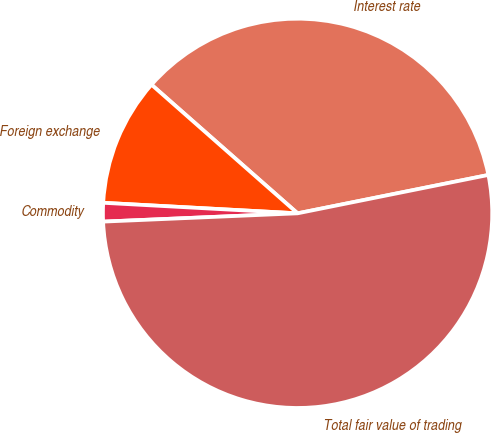Convert chart to OTSL. <chart><loc_0><loc_0><loc_500><loc_500><pie_chart><fcel>Interest rate<fcel>Foreign exchange<fcel>Commodity<fcel>Total fair value of trading<nl><fcel>35.35%<fcel>10.63%<fcel>1.54%<fcel>52.48%<nl></chart> 